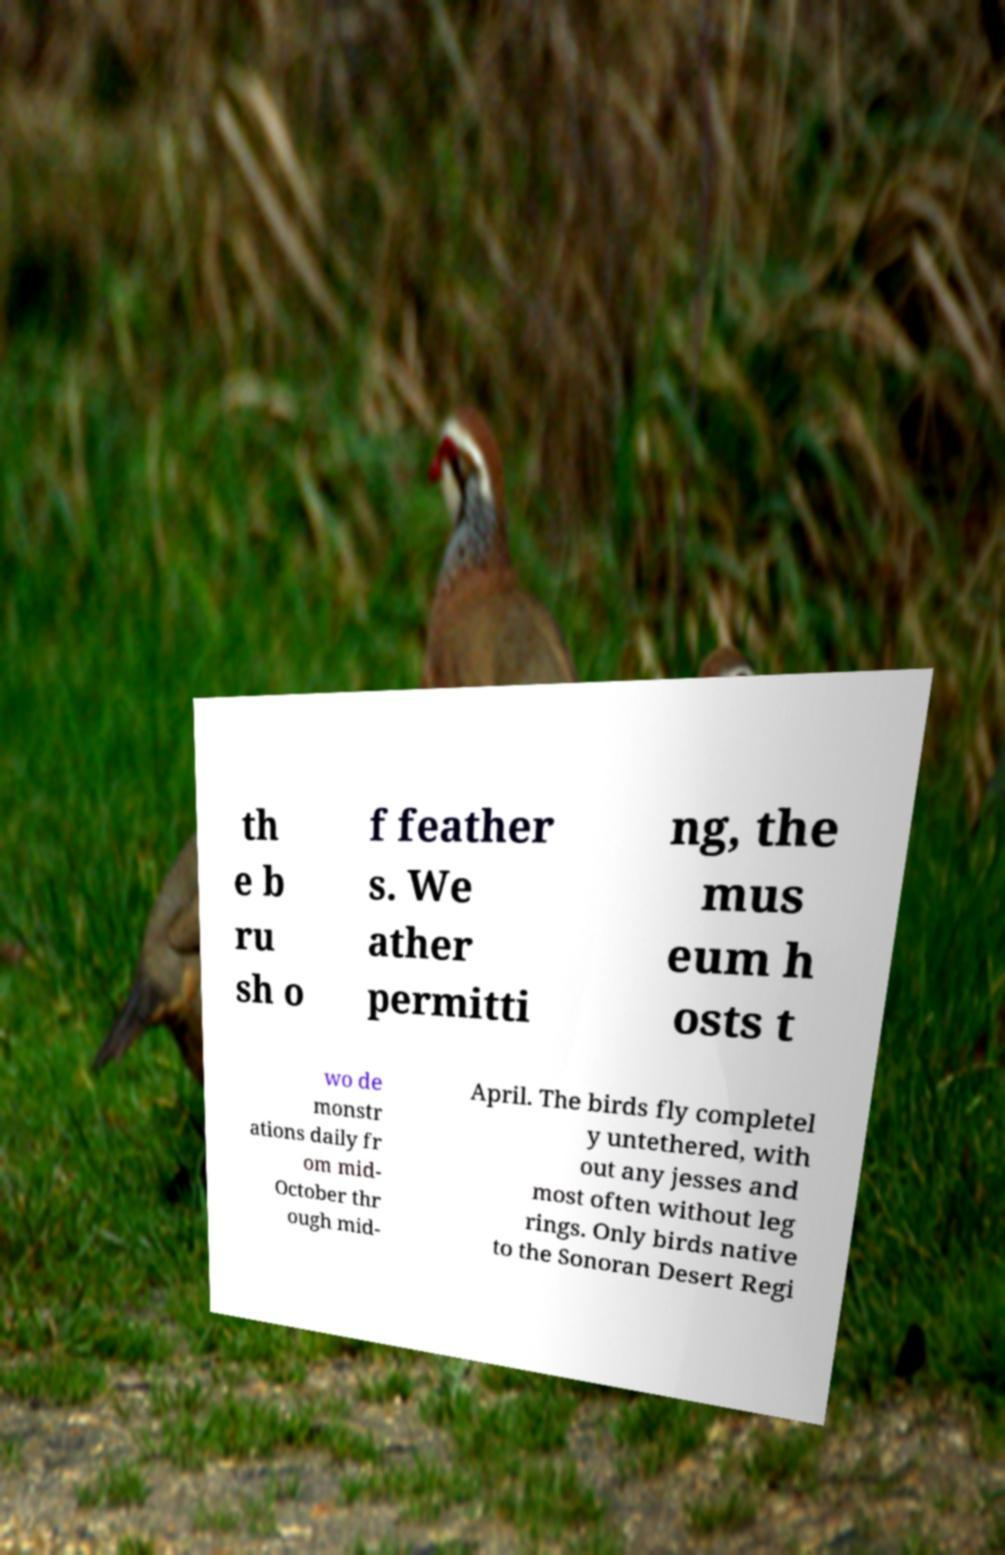Please identify and transcribe the text found in this image. th e b ru sh o f feather s. We ather permitti ng, the mus eum h osts t wo de monstr ations daily fr om mid- October thr ough mid- April. The birds fly completel y untethered, with out any jesses and most often without leg rings. Only birds native to the Sonoran Desert Regi 